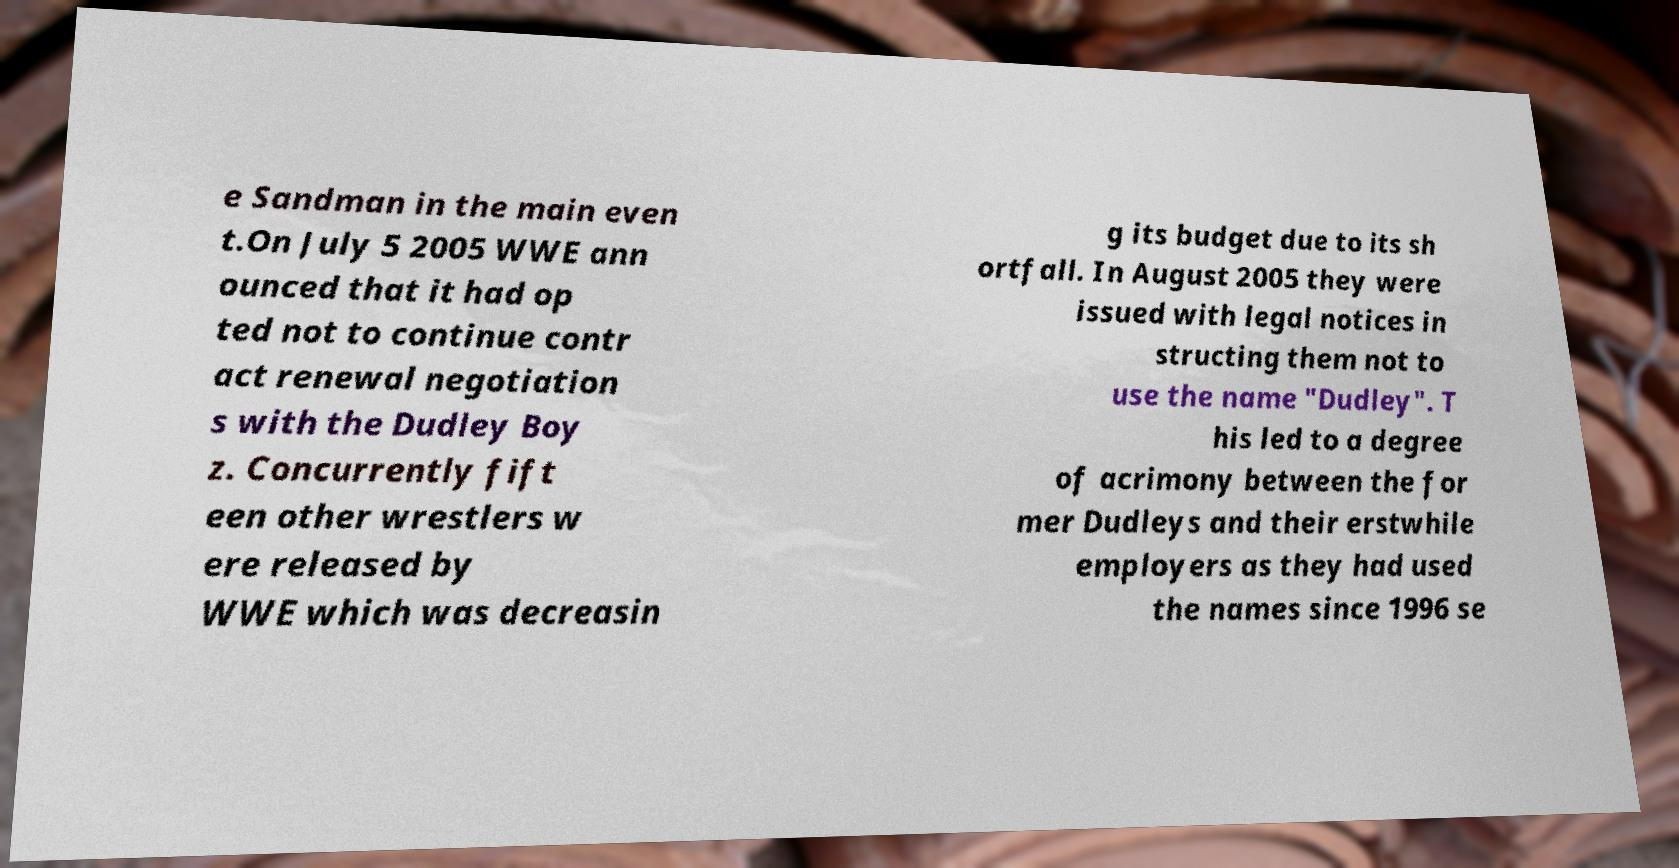Could you assist in decoding the text presented in this image and type it out clearly? e Sandman in the main even t.On July 5 2005 WWE ann ounced that it had op ted not to continue contr act renewal negotiation s with the Dudley Boy z. Concurrently fift een other wrestlers w ere released by WWE which was decreasin g its budget due to its sh ortfall. In August 2005 they were issued with legal notices in structing them not to use the name "Dudley". T his led to a degree of acrimony between the for mer Dudleys and their erstwhile employers as they had used the names since 1996 se 